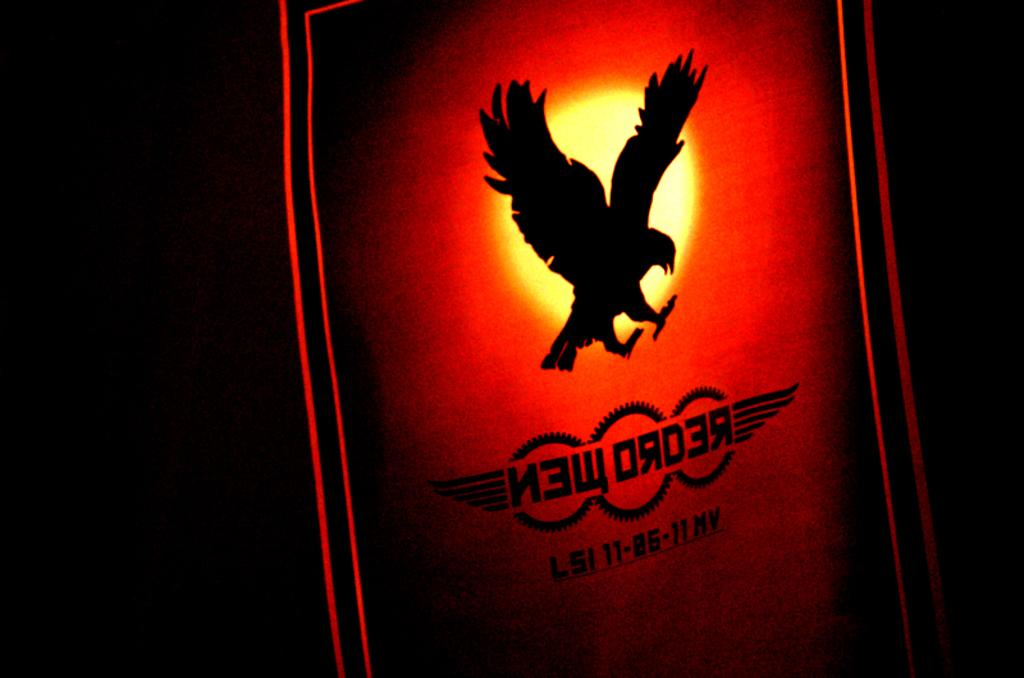What is the main object in the image? There is a board with light in the image. What is depicted on the board? The board has a painting of a bird. What can be seen in the sky in the image? The sun is visible in the image. What type of liquid can be seen flowing from the bird's stomach in the image? There is no bird or liquid present in the image; it features a board with a painting of a bird and a light. 